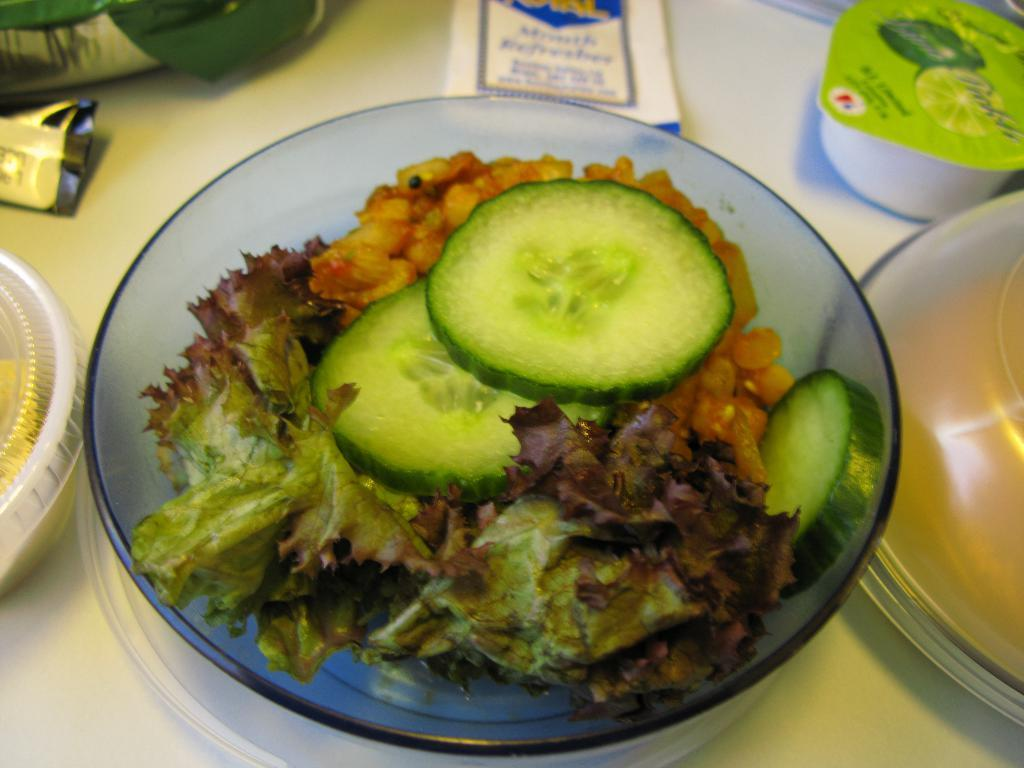What is located at the bottom of the image? There is a table at the bottom of the image. What items can be seen on the table? There are two packets, two boxes, a vessel, a plate, and a bowl with cucumber slices and a salad on the table. Can you describe the contents of the bowl? The bowl contains cucumber slices and a salad. What type of lace can be seen on the table in the image? There is no lace present on the table in the image. What direction is the voice coming from in the image? There is no voice present in the image. 